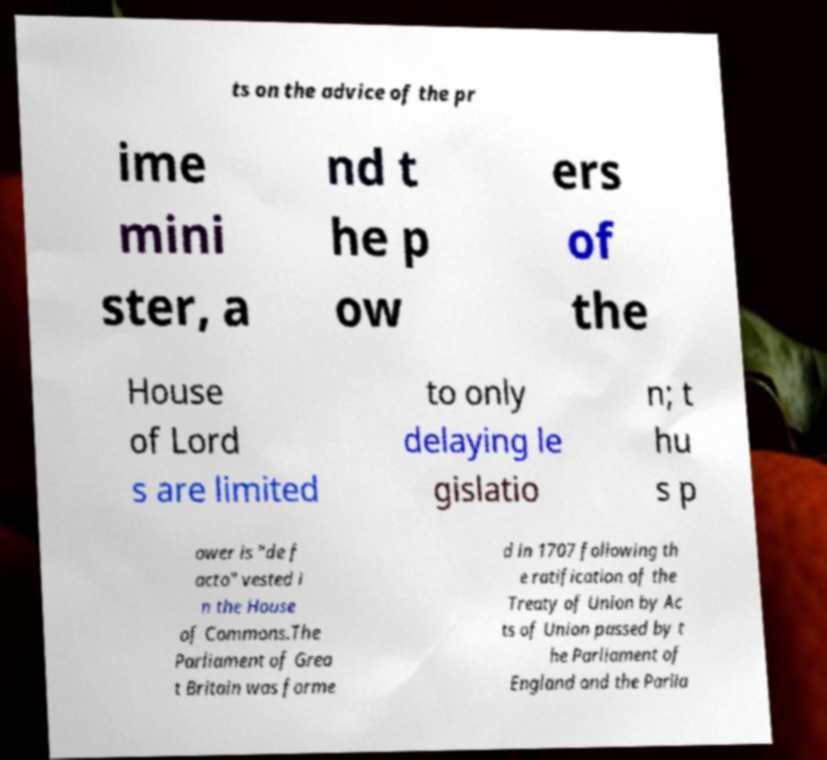Please read and relay the text visible in this image. What does it say? ts on the advice of the pr ime mini ster, a nd t he p ow ers of the House of Lord s are limited to only delaying le gislatio n; t hu s p ower is "de f acto" vested i n the House of Commons.The Parliament of Grea t Britain was forme d in 1707 following th e ratification of the Treaty of Union by Ac ts of Union passed by t he Parliament of England and the Parlia 